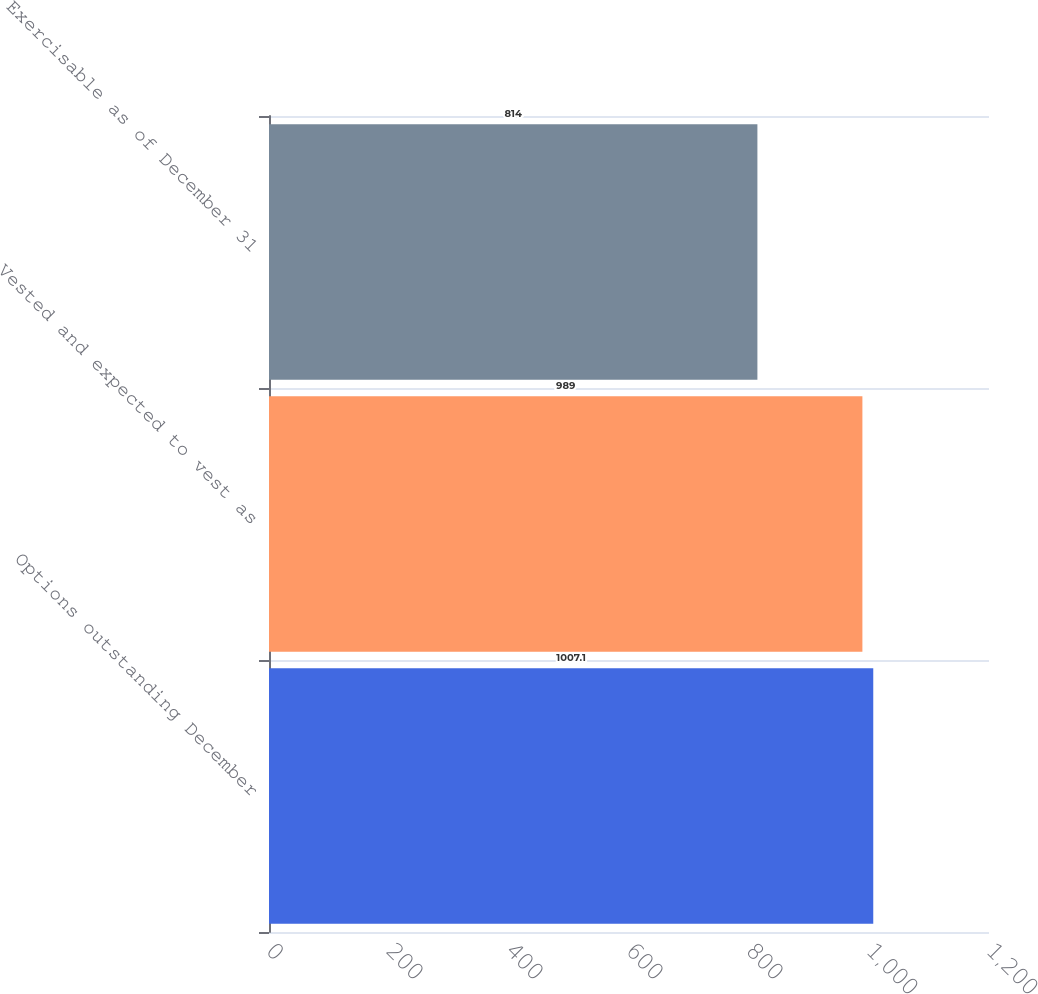Convert chart. <chart><loc_0><loc_0><loc_500><loc_500><bar_chart><fcel>Options outstanding December<fcel>Vested and expected to vest as<fcel>Exercisable as of December 31<nl><fcel>1007.1<fcel>989<fcel>814<nl></chart> 